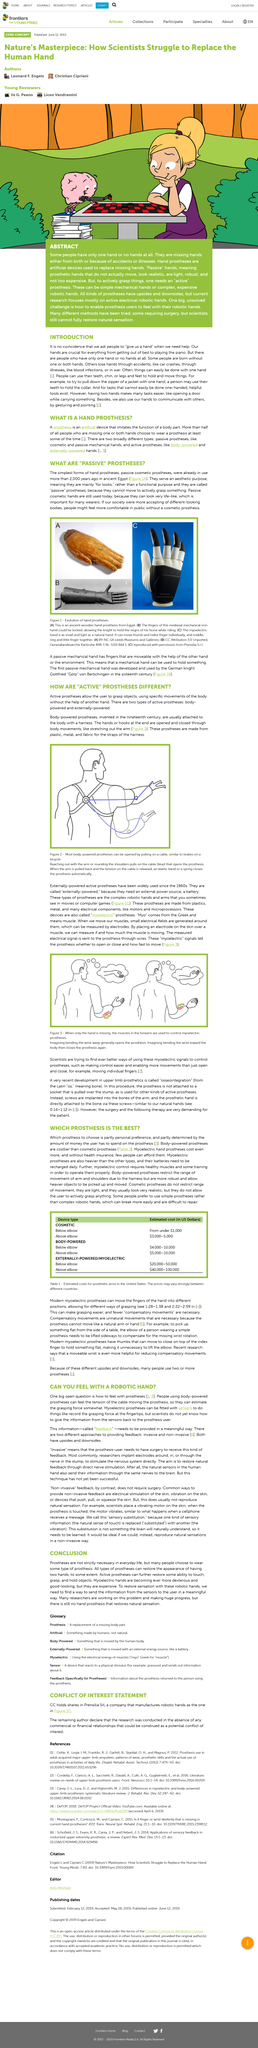List a handful of essential elements in this visual. The use of passive cosmetic prostheses is still prevalent today as they are able to replicate a lifelike appearance, which is highly valued by many individuals who use them. Myoelectric prostheses are the most expensive prosthetic devices available, making them the premier choice for individuals in need of a high-end prosthetic solution. There is no hand prosthesis that restores natural sensation. It is a common practice to ask for assistance by saying "give us a hand" when in need of help. Myoelectric prostheses, when equipped with sensors, are capable of recording the grasping force at the fingertips and other actions, allowing for more realistic and functional use. 